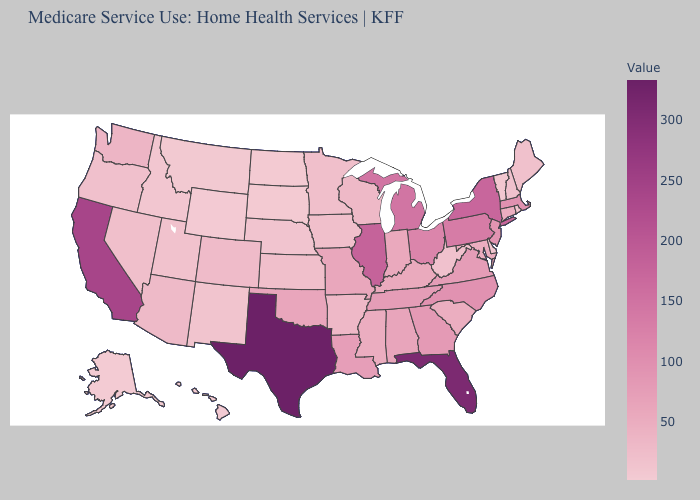Does Iowa have the highest value in the USA?
Write a very short answer. No. Does Kentucky have a higher value than Ohio?
Be succinct. No. 